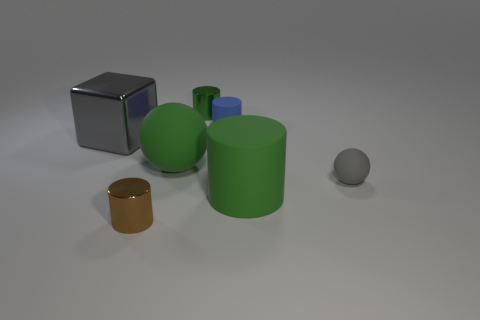Do the large cylinder and the big thing behind the big green ball have the same color?
Your answer should be very brief. No. Are there any shiny cubes of the same size as the blue matte thing?
Keep it short and to the point. No. The shiny thing that is the same color as the big ball is what size?
Make the answer very short. Small. What is the ball left of the green rubber cylinder made of?
Keep it short and to the point. Rubber. Are there the same number of things that are in front of the large green cylinder and big green matte objects behind the gray block?
Keep it short and to the point. No. There is a cylinder that is right of the blue object; does it have the same size as the gray thing left of the large green matte ball?
Keep it short and to the point. Yes. How many balls are the same color as the large cylinder?
Give a very brief answer. 1. There is a large thing that is the same color as the large sphere; what is it made of?
Give a very brief answer. Rubber. Is the number of large gray things that are in front of the small brown thing greater than the number of tiny gray balls?
Your answer should be compact. No. Is the shape of the tiny brown shiny thing the same as the big gray shiny thing?
Ensure brevity in your answer.  No. 